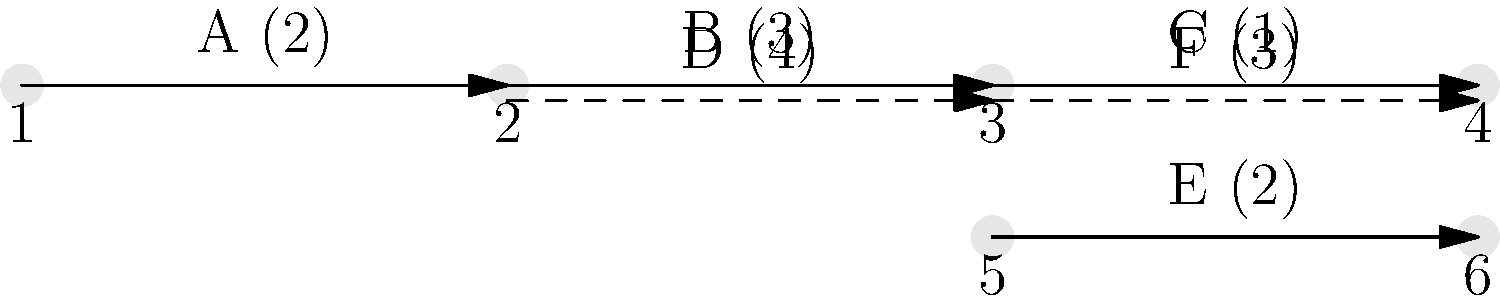As a project manager, you're overseeing a project with the network diagram shown above. Each activity is labeled with its duration in days. What is the critical path and the minimum project duration? To find the critical path and minimum project duration, we'll use the Critical Path Method (CPM):

1. Identify all paths:
   Path 1: A - B - C
   Path 2: A - B - F
   Path 3: A - D - E

2. Calculate the duration of each path:
   Path 1: A (2) + B (3) + C (1) = 6 days
   Path 2: A (2) + B (3) + F (3) = 8 days
   Path 3: A (2) + D (4) + E (2) = 8 days

3. Identify the critical path:
   The critical path is the longest path through the network. In this case, there are two paths with the same longest duration: Path 2 and Path 3, both taking 8 days.

4. Determine the minimum project duration:
   The minimum project duration is equal to the length of the critical path, which is 8 days.

5. Identify critical activities:
   The critical activities are those on the critical path(s). In this case:
   - Activity A (common to both paths)
   - Activities B and F (Path 2)
   - Activities D and E (Path 3)

As a project manager, it's crucial to focus on these critical activities, as any delay in them will directly impact the project's completion time. Non-critical activities (like C) have some float and can be slightly delayed without affecting the overall project duration.
Answer: Critical paths: A-B-F and A-D-E; Minimum duration: 8 days 